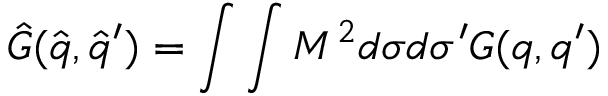<formula> <loc_0><loc_0><loc_500><loc_500>{ \hat { G } } ( { \hat { q } } , { \hat { q } } ^ { \prime } ) = \int \int M ^ { 2 } d { \sigma } d { \sigma } ^ { \prime } G ( q , q ^ { \prime } )</formula> 